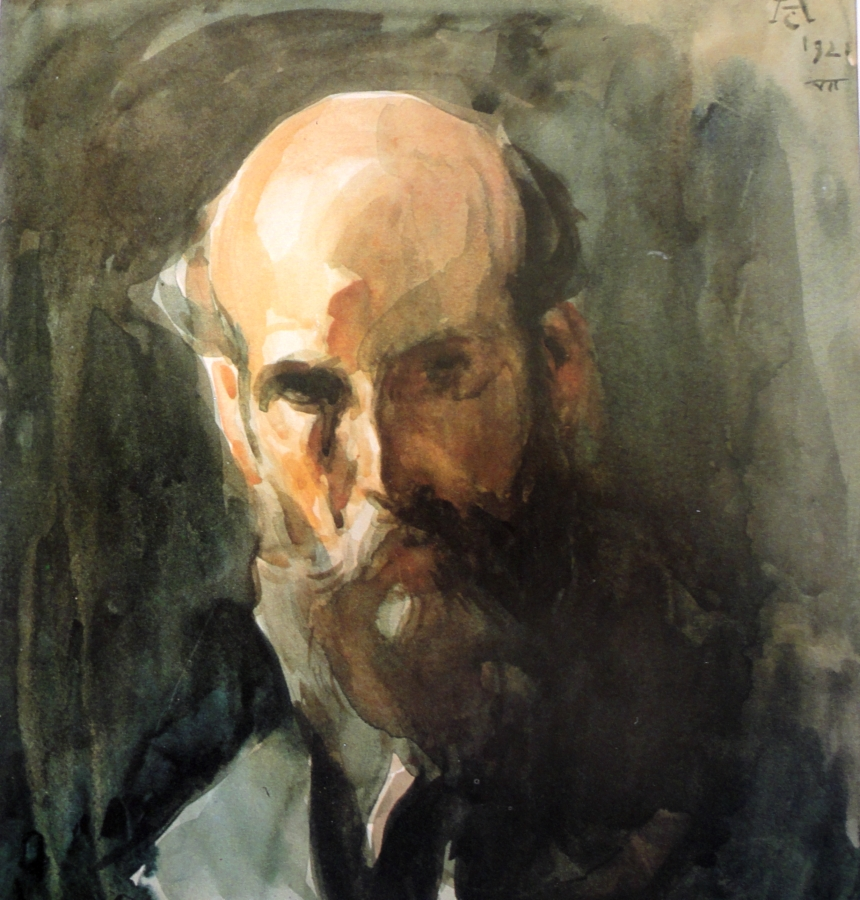Imagine the man in the painting coming to life and travelling through time. What significant event in history do you think he would witness and why? If the man in the painting could come to life and travel through time, he might witness the Renaissance period. As a philosopher and thinker, he would be drawn to an era marked by a revival of art, culture, and intellectual pursuit. The Renaissance was a time of profound transformation and discovery, aligning well with the contemplative expression captured in the portrait. Being present in such a dynamic and enlightened period could provide him with new insights and inspirations, intertwining his timeless wisdom with the vibrancy of Renaissance thought and creativity. 